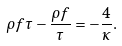<formula> <loc_0><loc_0><loc_500><loc_500>\rho f \tau - \frac { \rho f } { \tau } = - \frac { 4 } { \kappa } .</formula> 